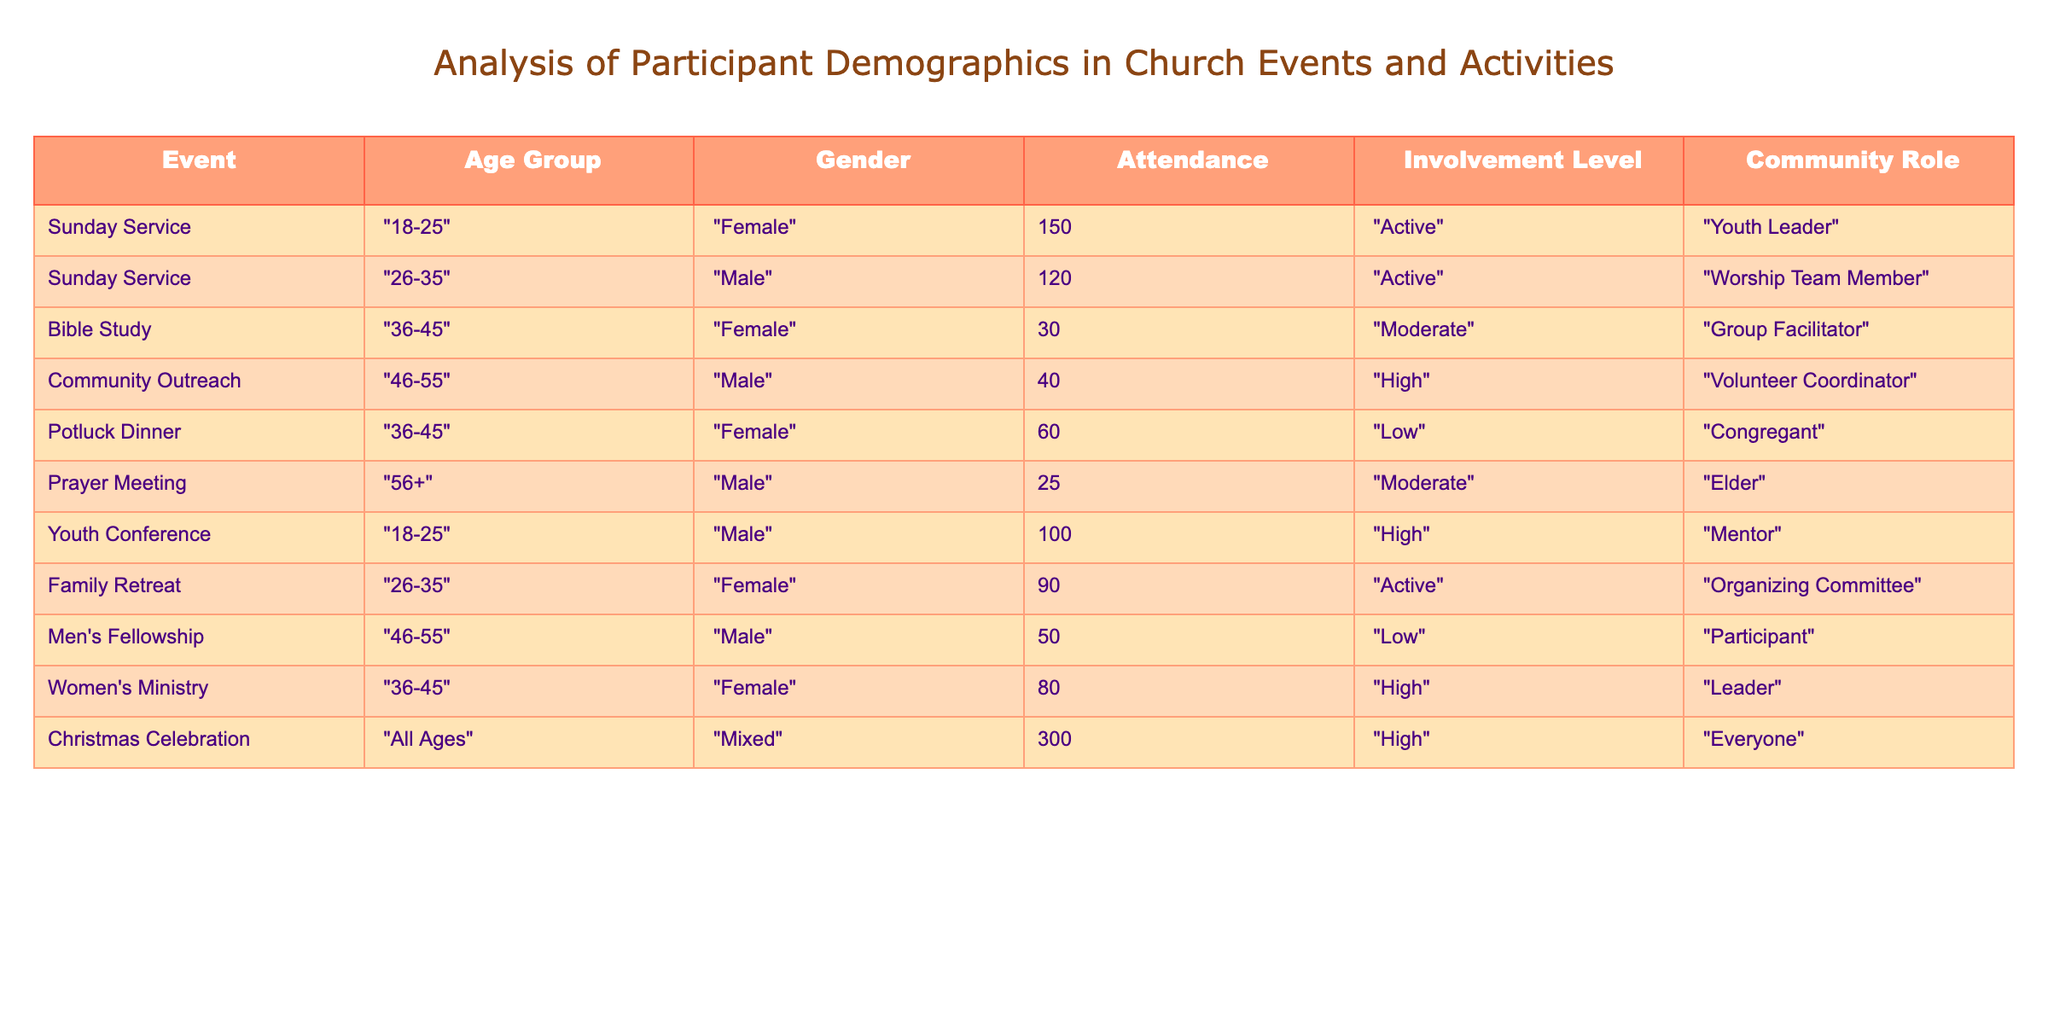What is the attendance for the Christmas Celebration? The attendance for the Christmas Celebration is listed directly in the table under the "Attendance" column for that event, which shows a value of 300.
Answer: 300 How many females participated in the Bible Study? In the table, the event "Bible Study" has a specified Gender as "Female" and the Attendance count for that event is 30. Thus, 30 females participated.
Answer: 30 What is the average attendance for events with a "High" involvement level? The events with a "High" involvement level are "Community Outreach" (40), "Youth Conference" (100), "Women's Ministry" (80), and "Christmas Celebration" (300). First, we sum these values: 40 + 100 + 80 + 300 = 520. There are 4 events, so the average is 520 / 4 = 130.
Answer: 130 Are there more males or females involved in the "Sunday Service"? In the "Sunday Service," there are 150 attendees who are female and 120 who are male. Since 150 is greater than 120, there are more females involved.
Answer: Yes What is the total attendance of all events for the age group "36-45"? The relevant events for the age group "36-45" are "Bible Study" (30), "Potluck Dinner" (60), and "Women's Ministry" (80). Adding these together gives us: 30 + 60 + 80 = 170. Therefore, the total attendance for the age group "36-45" is 170.
Answer: 170 Which community role has the highest attendance, and what is that attendance? Reviewing the table, the "Christmas Celebration" has the role "Everyone" and an attendance of 300, which is the highest overall in the table. Other roles do not exceed this number.
Answer: Everyone, 300 What is the difference in attendance between the "Youth Conference" and the "Prayer Meeting"? The "Youth Conference" has an attendance of 100 while the "Prayer Meeting" shows an attendance of 25. The difference in attendance is calculated as: 100 - 25 = 75.
Answer: 75 How many total events have an involvement level classified as "Active"? The events with an "Active" involvement level are "Sunday Service" (150), "Youth Conference" (100), and "Family Retreat" (90). The count of these events is 3.
Answer: 3 